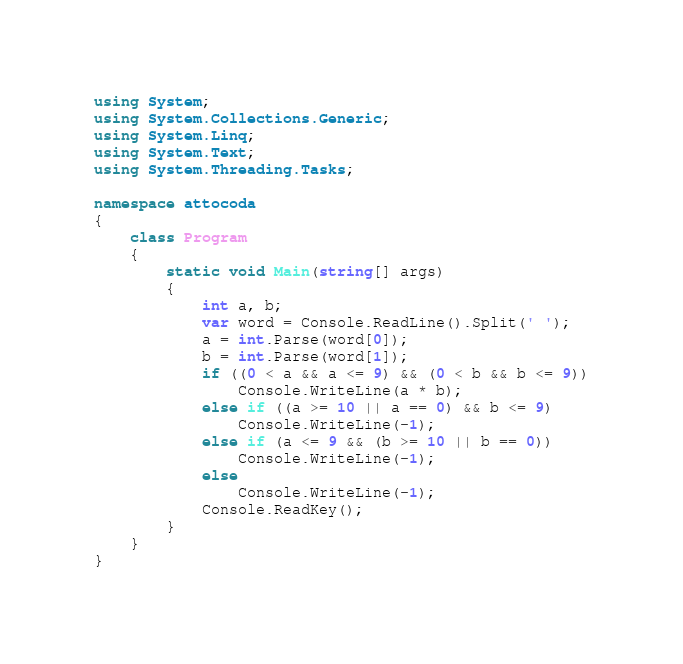Convert code to text. <code><loc_0><loc_0><loc_500><loc_500><_C#_>using System;
using System.Collections.Generic;
using System.Linq;
using System.Text;
using System.Threading.Tasks;

namespace attocoda
{
    class Program
    {
        static void Main(string[] args)
        {
            int a, b;
            var word = Console.ReadLine().Split(' ');
            a = int.Parse(word[0]);
            b = int.Parse(word[1]);
            if ((0 < a && a <= 9) && (0 < b && b <= 9))
                Console.WriteLine(a * b);
            else if ((a >= 10 || a == 0) && b <= 9)
                Console.WriteLine(-1);
            else if (a <= 9 && (b >= 10 || b == 0))
                Console.WriteLine(-1);
            else
                Console.WriteLine(-1);
            Console.ReadKey();
        }
    }
}
</code> 